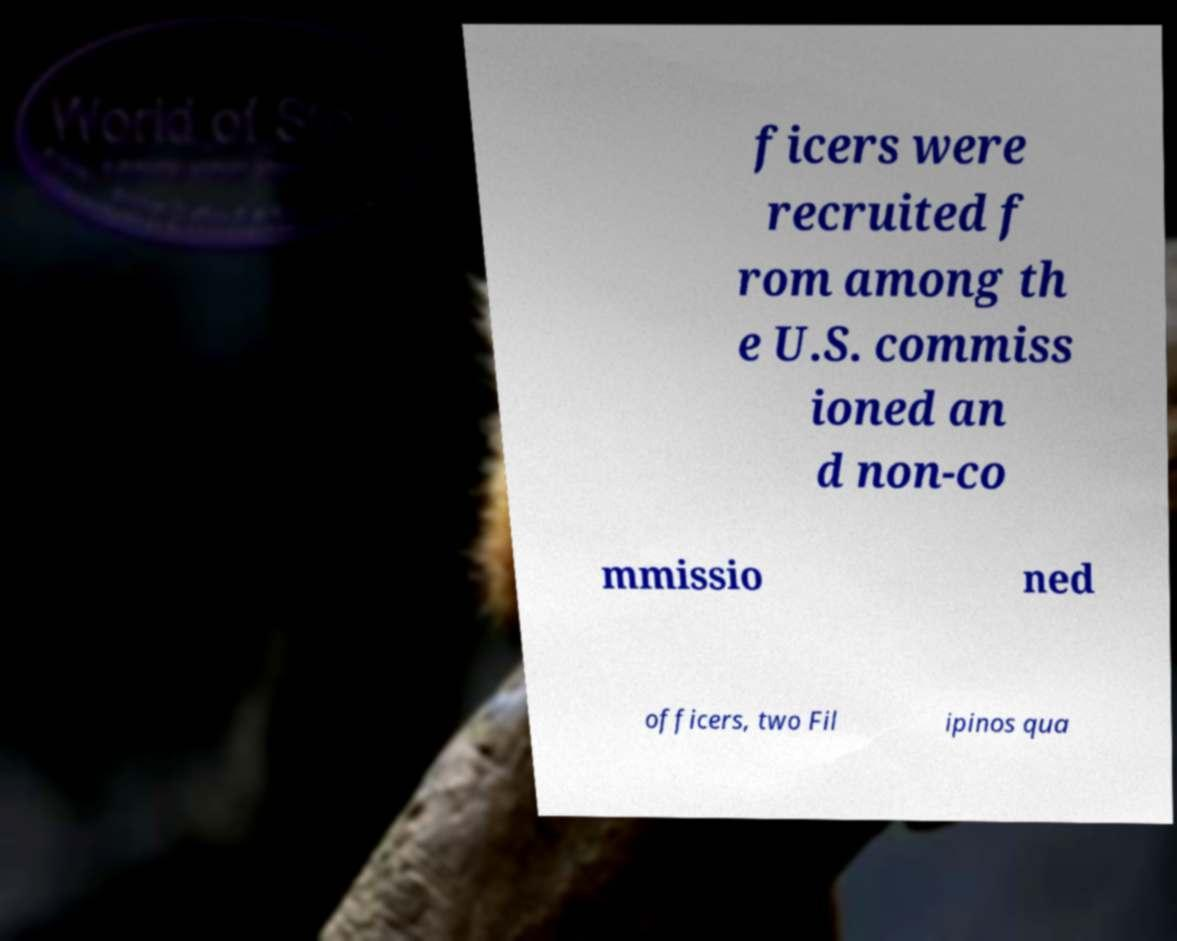Could you assist in decoding the text presented in this image and type it out clearly? ficers were recruited f rom among th e U.S. commiss ioned an d non-co mmissio ned officers, two Fil ipinos qua 